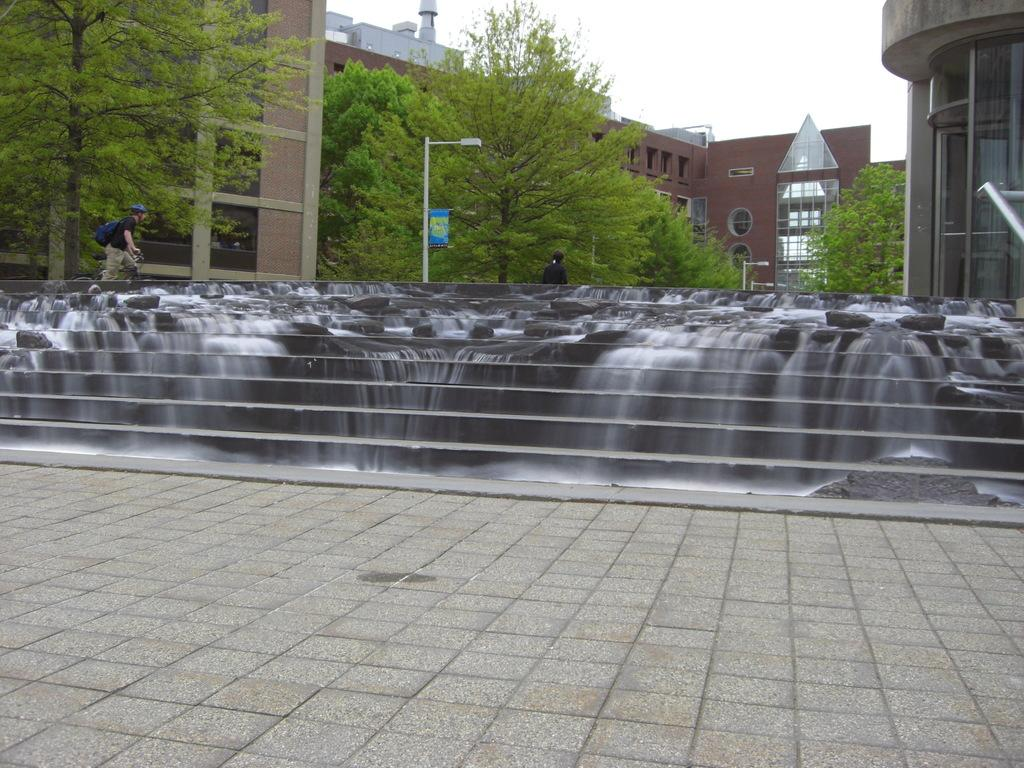What natural feature can be seen in the image? There is a waterfall in the image. Where is the waterfall located in relation to other elements in the image? The waterfall is on the stairs. What type of artificial light source is present in the image? There is a streetlight in the image. What can be seen in the distance in the image? There are buildings and trees in the background of the image. What type of breakfast is being served in the image? There is no breakfast present in the image; it features a waterfall on stairs, a streetlight, and buildings and trees in the background. 